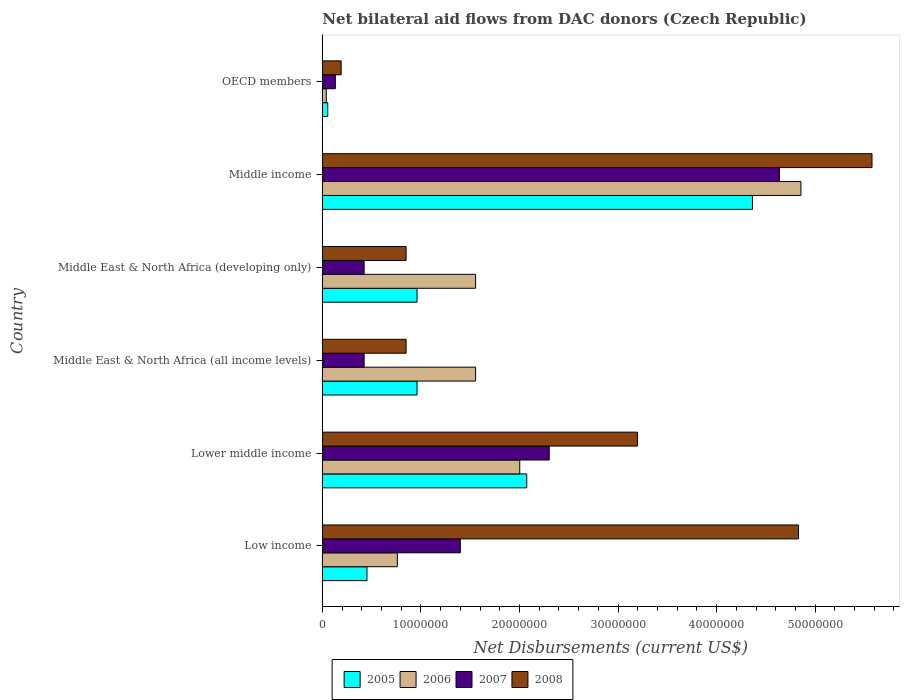How many different coloured bars are there?
Your answer should be compact. 4. Are the number of bars per tick equal to the number of legend labels?
Keep it short and to the point. Yes. How many bars are there on the 2nd tick from the top?
Offer a very short reply. 4. How many bars are there on the 6th tick from the bottom?
Your answer should be very brief. 4. In how many cases, is the number of bars for a given country not equal to the number of legend labels?
Provide a succinct answer. 0. What is the net bilateral aid flows in 2005 in Lower middle income?
Offer a terse response. 2.07e+07. Across all countries, what is the maximum net bilateral aid flows in 2008?
Keep it short and to the point. 5.58e+07. Across all countries, what is the minimum net bilateral aid flows in 2007?
Offer a very short reply. 1.32e+06. What is the total net bilateral aid flows in 2008 in the graph?
Your answer should be very brief. 1.55e+08. What is the difference between the net bilateral aid flows in 2008 in Middle East & North Africa (all income levels) and that in Middle income?
Offer a very short reply. -4.73e+07. What is the difference between the net bilateral aid flows in 2007 in Middle East & North Africa (all income levels) and the net bilateral aid flows in 2005 in Lower middle income?
Give a very brief answer. -1.65e+07. What is the average net bilateral aid flows in 2007 per country?
Your answer should be compact. 1.55e+07. What is the difference between the net bilateral aid flows in 2005 and net bilateral aid flows in 2006 in Middle East & North Africa (developing only)?
Your answer should be compact. -5.94e+06. What is the ratio of the net bilateral aid flows in 2008 in Low income to that in Middle East & North Africa (all income levels)?
Make the answer very short. 5.68. Is the difference between the net bilateral aid flows in 2005 in Lower middle income and Middle East & North Africa (developing only) greater than the difference between the net bilateral aid flows in 2006 in Lower middle income and Middle East & North Africa (developing only)?
Make the answer very short. Yes. What is the difference between the highest and the second highest net bilateral aid flows in 2005?
Offer a terse response. 2.29e+07. What is the difference between the highest and the lowest net bilateral aid flows in 2006?
Offer a terse response. 4.82e+07. What does the 2nd bar from the top in Middle East & North Africa (all income levels) represents?
Make the answer very short. 2007. Is it the case that in every country, the sum of the net bilateral aid flows in 2006 and net bilateral aid flows in 2005 is greater than the net bilateral aid flows in 2008?
Your answer should be very brief. No. Are all the bars in the graph horizontal?
Provide a succinct answer. Yes. How many countries are there in the graph?
Offer a very short reply. 6. What is the difference between two consecutive major ticks on the X-axis?
Your response must be concise. 1.00e+07. Are the values on the major ticks of X-axis written in scientific E-notation?
Keep it short and to the point. No. Does the graph contain any zero values?
Ensure brevity in your answer.  No. Does the graph contain grids?
Your answer should be compact. No. Where does the legend appear in the graph?
Keep it short and to the point. Bottom center. How are the legend labels stacked?
Ensure brevity in your answer.  Horizontal. What is the title of the graph?
Keep it short and to the point. Net bilateral aid flows from DAC donors (Czech Republic). What is the label or title of the X-axis?
Offer a terse response. Net Disbursements (current US$). What is the Net Disbursements (current US$) of 2005 in Low income?
Give a very brief answer. 4.53e+06. What is the Net Disbursements (current US$) in 2006 in Low income?
Keep it short and to the point. 7.61e+06. What is the Net Disbursements (current US$) in 2007 in Low income?
Your answer should be very brief. 1.40e+07. What is the Net Disbursements (current US$) in 2008 in Low income?
Keep it short and to the point. 4.83e+07. What is the Net Disbursements (current US$) in 2005 in Lower middle income?
Keep it short and to the point. 2.07e+07. What is the Net Disbursements (current US$) in 2006 in Lower middle income?
Make the answer very short. 2.00e+07. What is the Net Disbursements (current US$) in 2007 in Lower middle income?
Your response must be concise. 2.30e+07. What is the Net Disbursements (current US$) of 2008 in Lower middle income?
Offer a very short reply. 3.20e+07. What is the Net Disbursements (current US$) in 2005 in Middle East & North Africa (all income levels)?
Offer a very short reply. 9.61e+06. What is the Net Disbursements (current US$) of 2006 in Middle East & North Africa (all income levels)?
Make the answer very short. 1.56e+07. What is the Net Disbursements (current US$) in 2007 in Middle East & North Africa (all income levels)?
Give a very brief answer. 4.24e+06. What is the Net Disbursements (current US$) of 2008 in Middle East & North Africa (all income levels)?
Offer a terse response. 8.50e+06. What is the Net Disbursements (current US$) in 2005 in Middle East & North Africa (developing only)?
Offer a very short reply. 9.61e+06. What is the Net Disbursements (current US$) in 2006 in Middle East & North Africa (developing only)?
Offer a very short reply. 1.56e+07. What is the Net Disbursements (current US$) of 2007 in Middle East & North Africa (developing only)?
Provide a short and direct response. 4.24e+06. What is the Net Disbursements (current US$) of 2008 in Middle East & North Africa (developing only)?
Offer a terse response. 8.50e+06. What is the Net Disbursements (current US$) in 2005 in Middle income?
Your answer should be very brief. 4.36e+07. What is the Net Disbursements (current US$) of 2006 in Middle income?
Make the answer very short. 4.86e+07. What is the Net Disbursements (current US$) of 2007 in Middle income?
Provide a succinct answer. 4.64e+07. What is the Net Disbursements (current US$) in 2008 in Middle income?
Your response must be concise. 5.58e+07. What is the Net Disbursements (current US$) in 2006 in OECD members?
Keep it short and to the point. 4.00e+05. What is the Net Disbursements (current US$) of 2007 in OECD members?
Make the answer very short. 1.32e+06. What is the Net Disbursements (current US$) in 2008 in OECD members?
Offer a very short reply. 1.91e+06. Across all countries, what is the maximum Net Disbursements (current US$) in 2005?
Offer a very short reply. 4.36e+07. Across all countries, what is the maximum Net Disbursements (current US$) in 2006?
Offer a terse response. 4.86e+07. Across all countries, what is the maximum Net Disbursements (current US$) in 2007?
Offer a terse response. 4.64e+07. Across all countries, what is the maximum Net Disbursements (current US$) in 2008?
Your answer should be compact. 5.58e+07. Across all countries, what is the minimum Net Disbursements (current US$) of 2005?
Your response must be concise. 5.50e+05. Across all countries, what is the minimum Net Disbursements (current US$) of 2006?
Provide a succinct answer. 4.00e+05. Across all countries, what is the minimum Net Disbursements (current US$) in 2007?
Offer a very short reply. 1.32e+06. Across all countries, what is the minimum Net Disbursements (current US$) in 2008?
Offer a very short reply. 1.91e+06. What is the total Net Disbursements (current US$) of 2005 in the graph?
Offer a very short reply. 8.87e+07. What is the total Net Disbursements (current US$) of 2006 in the graph?
Offer a terse response. 1.08e+08. What is the total Net Disbursements (current US$) in 2007 in the graph?
Make the answer very short. 9.32e+07. What is the total Net Disbursements (current US$) of 2008 in the graph?
Provide a succinct answer. 1.55e+08. What is the difference between the Net Disbursements (current US$) of 2005 in Low income and that in Lower middle income?
Your answer should be compact. -1.62e+07. What is the difference between the Net Disbursements (current US$) of 2006 in Low income and that in Lower middle income?
Your answer should be very brief. -1.24e+07. What is the difference between the Net Disbursements (current US$) in 2007 in Low income and that in Lower middle income?
Provide a succinct answer. -9.02e+06. What is the difference between the Net Disbursements (current US$) in 2008 in Low income and that in Lower middle income?
Provide a short and direct response. 1.63e+07. What is the difference between the Net Disbursements (current US$) in 2005 in Low income and that in Middle East & North Africa (all income levels)?
Provide a succinct answer. -5.08e+06. What is the difference between the Net Disbursements (current US$) of 2006 in Low income and that in Middle East & North Africa (all income levels)?
Make the answer very short. -7.94e+06. What is the difference between the Net Disbursements (current US$) of 2007 in Low income and that in Middle East & North Africa (all income levels)?
Provide a succinct answer. 9.76e+06. What is the difference between the Net Disbursements (current US$) of 2008 in Low income and that in Middle East & North Africa (all income levels)?
Your response must be concise. 3.98e+07. What is the difference between the Net Disbursements (current US$) of 2005 in Low income and that in Middle East & North Africa (developing only)?
Your answer should be compact. -5.08e+06. What is the difference between the Net Disbursements (current US$) in 2006 in Low income and that in Middle East & North Africa (developing only)?
Make the answer very short. -7.94e+06. What is the difference between the Net Disbursements (current US$) of 2007 in Low income and that in Middle East & North Africa (developing only)?
Offer a terse response. 9.76e+06. What is the difference between the Net Disbursements (current US$) of 2008 in Low income and that in Middle East & North Africa (developing only)?
Offer a very short reply. 3.98e+07. What is the difference between the Net Disbursements (current US$) of 2005 in Low income and that in Middle income?
Provide a succinct answer. -3.91e+07. What is the difference between the Net Disbursements (current US$) in 2006 in Low income and that in Middle income?
Offer a terse response. -4.10e+07. What is the difference between the Net Disbursements (current US$) in 2007 in Low income and that in Middle income?
Keep it short and to the point. -3.24e+07. What is the difference between the Net Disbursements (current US$) in 2008 in Low income and that in Middle income?
Give a very brief answer. -7.46e+06. What is the difference between the Net Disbursements (current US$) in 2005 in Low income and that in OECD members?
Ensure brevity in your answer.  3.98e+06. What is the difference between the Net Disbursements (current US$) of 2006 in Low income and that in OECD members?
Ensure brevity in your answer.  7.21e+06. What is the difference between the Net Disbursements (current US$) in 2007 in Low income and that in OECD members?
Your answer should be compact. 1.27e+07. What is the difference between the Net Disbursements (current US$) in 2008 in Low income and that in OECD members?
Provide a succinct answer. 4.64e+07. What is the difference between the Net Disbursements (current US$) of 2005 in Lower middle income and that in Middle East & North Africa (all income levels)?
Your answer should be compact. 1.11e+07. What is the difference between the Net Disbursements (current US$) of 2006 in Lower middle income and that in Middle East & North Africa (all income levels)?
Your response must be concise. 4.48e+06. What is the difference between the Net Disbursements (current US$) in 2007 in Lower middle income and that in Middle East & North Africa (all income levels)?
Give a very brief answer. 1.88e+07. What is the difference between the Net Disbursements (current US$) in 2008 in Lower middle income and that in Middle East & North Africa (all income levels)?
Ensure brevity in your answer.  2.35e+07. What is the difference between the Net Disbursements (current US$) in 2005 in Lower middle income and that in Middle East & North Africa (developing only)?
Offer a terse response. 1.11e+07. What is the difference between the Net Disbursements (current US$) of 2006 in Lower middle income and that in Middle East & North Africa (developing only)?
Your response must be concise. 4.48e+06. What is the difference between the Net Disbursements (current US$) of 2007 in Lower middle income and that in Middle East & North Africa (developing only)?
Ensure brevity in your answer.  1.88e+07. What is the difference between the Net Disbursements (current US$) of 2008 in Lower middle income and that in Middle East & North Africa (developing only)?
Provide a succinct answer. 2.35e+07. What is the difference between the Net Disbursements (current US$) of 2005 in Lower middle income and that in Middle income?
Provide a succinct answer. -2.29e+07. What is the difference between the Net Disbursements (current US$) of 2006 in Lower middle income and that in Middle income?
Offer a terse response. -2.85e+07. What is the difference between the Net Disbursements (current US$) in 2007 in Lower middle income and that in Middle income?
Your answer should be very brief. -2.34e+07. What is the difference between the Net Disbursements (current US$) in 2008 in Lower middle income and that in Middle income?
Your answer should be compact. -2.38e+07. What is the difference between the Net Disbursements (current US$) in 2005 in Lower middle income and that in OECD members?
Make the answer very short. 2.02e+07. What is the difference between the Net Disbursements (current US$) of 2006 in Lower middle income and that in OECD members?
Provide a succinct answer. 1.96e+07. What is the difference between the Net Disbursements (current US$) of 2007 in Lower middle income and that in OECD members?
Provide a succinct answer. 2.17e+07. What is the difference between the Net Disbursements (current US$) of 2008 in Lower middle income and that in OECD members?
Give a very brief answer. 3.01e+07. What is the difference between the Net Disbursements (current US$) of 2007 in Middle East & North Africa (all income levels) and that in Middle East & North Africa (developing only)?
Offer a very short reply. 0. What is the difference between the Net Disbursements (current US$) of 2005 in Middle East & North Africa (all income levels) and that in Middle income?
Your answer should be compact. -3.40e+07. What is the difference between the Net Disbursements (current US$) in 2006 in Middle East & North Africa (all income levels) and that in Middle income?
Keep it short and to the point. -3.30e+07. What is the difference between the Net Disbursements (current US$) of 2007 in Middle East & North Africa (all income levels) and that in Middle income?
Your response must be concise. -4.21e+07. What is the difference between the Net Disbursements (current US$) in 2008 in Middle East & North Africa (all income levels) and that in Middle income?
Provide a succinct answer. -4.73e+07. What is the difference between the Net Disbursements (current US$) of 2005 in Middle East & North Africa (all income levels) and that in OECD members?
Your response must be concise. 9.06e+06. What is the difference between the Net Disbursements (current US$) of 2006 in Middle East & North Africa (all income levels) and that in OECD members?
Provide a succinct answer. 1.52e+07. What is the difference between the Net Disbursements (current US$) in 2007 in Middle East & North Africa (all income levels) and that in OECD members?
Ensure brevity in your answer.  2.92e+06. What is the difference between the Net Disbursements (current US$) of 2008 in Middle East & North Africa (all income levels) and that in OECD members?
Ensure brevity in your answer.  6.59e+06. What is the difference between the Net Disbursements (current US$) in 2005 in Middle East & North Africa (developing only) and that in Middle income?
Keep it short and to the point. -3.40e+07. What is the difference between the Net Disbursements (current US$) in 2006 in Middle East & North Africa (developing only) and that in Middle income?
Give a very brief answer. -3.30e+07. What is the difference between the Net Disbursements (current US$) of 2007 in Middle East & North Africa (developing only) and that in Middle income?
Offer a very short reply. -4.21e+07. What is the difference between the Net Disbursements (current US$) of 2008 in Middle East & North Africa (developing only) and that in Middle income?
Your response must be concise. -4.73e+07. What is the difference between the Net Disbursements (current US$) of 2005 in Middle East & North Africa (developing only) and that in OECD members?
Provide a succinct answer. 9.06e+06. What is the difference between the Net Disbursements (current US$) of 2006 in Middle East & North Africa (developing only) and that in OECD members?
Offer a terse response. 1.52e+07. What is the difference between the Net Disbursements (current US$) in 2007 in Middle East & North Africa (developing only) and that in OECD members?
Your response must be concise. 2.92e+06. What is the difference between the Net Disbursements (current US$) of 2008 in Middle East & North Africa (developing only) and that in OECD members?
Your response must be concise. 6.59e+06. What is the difference between the Net Disbursements (current US$) of 2005 in Middle income and that in OECD members?
Ensure brevity in your answer.  4.31e+07. What is the difference between the Net Disbursements (current US$) in 2006 in Middle income and that in OECD members?
Keep it short and to the point. 4.82e+07. What is the difference between the Net Disbursements (current US$) of 2007 in Middle income and that in OECD members?
Your response must be concise. 4.51e+07. What is the difference between the Net Disbursements (current US$) of 2008 in Middle income and that in OECD members?
Offer a very short reply. 5.39e+07. What is the difference between the Net Disbursements (current US$) of 2005 in Low income and the Net Disbursements (current US$) of 2006 in Lower middle income?
Provide a short and direct response. -1.55e+07. What is the difference between the Net Disbursements (current US$) of 2005 in Low income and the Net Disbursements (current US$) of 2007 in Lower middle income?
Make the answer very short. -1.85e+07. What is the difference between the Net Disbursements (current US$) in 2005 in Low income and the Net Disbursements (current US$) in 2008 in Lower middle income?
Your answer should be very brief. -2.74e+07. What is the difference between the Net Disbursements (current US$) of 2006 in Low income and the Net Disbursements (current US$) of 2007 in Lower middle income?
Offer a very short reply. -1.54e+07. What is the difference between the Net Disbursements (current US$) in 2006 in Low income and the Net Disbursements (current US$) in 2008 in Lower middle income?
Provide a succinct answer. -2.44e+07. What is the difference between the Net Disbursements (current US$) in 2007 in Low income and the Net Disbursements (current US$) in 2008 in Lower middle income?
Your response must be concise. -1.80e+07. What is the difference between the Net Disbursements (current US$) of 2005 in Low income and the Net Disbursements (current US$) of 2006 in Middle East & North Africa (all income levels)?
Give a very brief answer. -1.10e+07. What is the difference between the Net Disbursements (current US$) in 2005 in Low income and the Net Disbursements (current US$) in 2008 in Middle East & North Africa (all income levels)?
Your answer should be very brief. -3.97e+06. What is the difference between the Net Disbursements (current US$) of 2006 in Low income and the Net Disbursements (current US$) of 2007 in Middle East & North Africa (all income levels)?
Your answer should be very brief. 3.37e+06. What is the difference between the Net Disbursements (current US$) of 2006 in Low income and the Net Disbursements (current US$) of 2008 in Middle East & North Africa (all income levels)?
Ensure brevity in your answer.  -8.90e+05. What is the difference between the Net Disbursements (current US$) of 2007 in Low income and the Net Disbursements (current US$) of 2008 in Middle East & North Africa (all income levels)?
Give a very brief answer. 5.50e+06. What is the difference between the Net Disbursements (current US$) in 2005 in Low income and the Net Disbursements (current US$) in 2006 in Middle East & North Africa (developing only)?
Keep it short and to the point. -1.10e+07. What is the difference between the Net Disbursements (current US$) of 2005 in Low income and the Net Disbursements (current US$) of 2007 in Middle East & North Africa (developing only)?
Ensure brevity in your answer.  2.90e+05. What is the difference between the Net Disbursements (current US$) in 2005 in Low income and the Net Disbursements (current US$) in 2008 in Middle East & North Africa (developing only)?
Provide a succinct answer. -3.97e+06. What is the difference between the Net Disbursements (current US$) in 2006 in Low income and the Net Disbursements (current US$) in 2007 in Middle East & North Africa (developing only)?
Your response must be concise. 3.37e+06. What is the difference between the Net Disbursements (current US$) in 2006 in Low income and the Net Disbursements (current US$) in 2008 in Middle East & North Africa (developing only)?
Offer a terse response. -8.90e+05. What is the difference between the Net Disbursements (current US$) in 2007 in Low income and the Net Disbursements (current US$) in 2008 in Middle East & North Africa (developing only)?
Offer a very short reply. 5.50e+06. What is the difference between the Net Disbursements (current US$) in 2005 in Low income and the Net Disbursements (current US$) in 2006 in Middle income?
Ensure brevity in your answer.  -4.40e+07. What is the difference between the Net Disbursements (current US$) of 2005 in Low income and the Net Disbursements (current US$) of 2007 in Middle income?
Ensure brevity in your answer.  -4.18e+07. What is the difference between the Net Disbursements (current US$) of 2005 in Low income and the Net Disbursements (current US$) of 2008 in Middle income?
Provide a succinct answer. -5.12e+07. What is the difference between the Net Disbursements (current US$) of 2006 in Low income and the Net Disbursements (current US$) of 2007 in Middle income?
Provide a succinct answer. -3.88e+07. What is the difference between the Net Disbursements (current US$) in 2006 in Low income and the Net Disbursements (current US$) in 2008 in Middle income?
Your response must be concise. -4.82e+07. What is the difference between the Net Disbursements (current US$) in 2007 in Low income and the Net Disbursements (current US$) in 2008 in Middle income?
Provide a short and direct response. -4.18e+07. What is the difference between the Net Disbursements (current US$) of 2005 in Low income and the Net Disbursements (current US$) of 2006 in OECD members?
Provide a succinct answer. 4.13e+06. What is the difference between the Net Disbursements (current US$) of 2005 in Low income and the Net Disbursements (current US$) of 2007 in OECD members?
Ensure brevity in your answer.  3.21e+06. What is the difference between the Net Disbursements (current US$) of 2005 in Low income and the Net Disbursements (current US$) of 2008 in OECD members?
Keep it short and to the point. 2.62e+06. What is the difference between the Net Disbursements (current US$) of 2006 in Low income and the Net Disbursements (current US$) of 2007 in OECD members?
Your answer should be very brief. 6.29e+06. What is the difference between the Net Disbursements (current US$) of 2006 in Low income and the Net Disbursements (current US$) of 2008 in OECD members?
Your response must be concise. 5.70e+06. What is the difference between the Net Disbursements (current US$) of 2007 in Low income and the Net Disbursements (current US$) of 2008 in OECD members?
Ensure brevity in your answer.  1.21e+07. What is the difference between the Net Disbursements (current US$) in 2005 in Lower middle income and the Net Disbursements (current US$) in 2006 in Middle East & North Africa (all income levels)?
Your answer should be very brief. 5.19e+06. What is the difference between the Net Disbursements (current US$) of 2005 in Lower middle income and the Net Disbursements (current US$) of 2007 in Middle East & North Africa (all income levels)?
Your answer should be compact. 1.65e+07. What is the difference between the Net Disbursements (current US$) of 2005 in Lower middle income and the Net Disbursements (current US$) of 2008 in Middle East & North Africa (all income levels)?
Provide a succinct answer. 1.22e+07. What is the difference between the Net Disbursements (current US$) of 2006 in Lower middle income and the Net Disbursements (current US$) of 2007 in Middle East & North Africa (all income levels)?
Your response must be concise. 1.58e+07. What is the difference between the Net Disbursements (current US$) of 2006 in Lower middle income and the Net Disbursements (current US$) of 2008 in Middle East & North Africa (all income levels)?
Provide a succinct answer. 1.15e+07. What is the difference between the Net Disbursements (current US$) of 2007 in Lower middle income and the Net Disbursements (current US$) of 2008 in Middle East & North Africa (all income levels)?
Your answer should be compact. 1.45e+07. What is the difference between the Net Disbursements (current US$) in 2005 in Lower middle income and the Net Disbursements (current US$) in 2006 in Middle East & North Africa (developing only)?
Provide a short and direct response. 5.19e+06. What is the difference between the Net Disbursements (current US$) of 2005 in Lower middle income and the Net Disbursements (current US$) of 2007 in Middle East & North Africa (developing only)?
Your answer should be very brief. 1.65e+07. What is the difference between the Net Disbursements (current US$) in 2005 in Lower middle income and the Net Disbursements (current US$) in 2008 in Middle East & North Africa (developing only)?
Your answer should be compact. 1.22e+07. What is the difference between the Net Disbursements (current US$) in 2006 in Lower middle income and the Net Disbursements (current US$) in 2007 in Middle East & North Africa (developing only)?
Your answer should be compact. 1.58e+07. What is the difference between the Net Disbursements (current US$) of 2006 in Lower middle income and the Net Disbursements (current US$) of 2008 in Middle East & North Africa (developing only)?
Offer a terse response. 1.15e+07. What is the difference between the Net Disbursements (current US$) in 2007 in Lower middle income and the Net Disbursements (current US$) in 2008 in Middle East & North Africa (developing only)?
Provide a short and direct response. 1.45e+07. What is the difference between the Net Disbursements (current US$) of 2005 in Lower middle income and the Net Disbursements (current US$) of 2006 in Middle income?
Offer a terse response. -2.78e+07. What is the difference between the Net Disbursements (current US$) in 2005 in Lower middle income and the Net Disbursements (current US$) in 2007 in Middle income?
Your answer should be very brief. -2.56e+07. What is the difference between the Net Disbursements (current US$) in 2005 in Lower middle income and the Net Disbursements (current US$) in 2008 in Middle income?
Make the answer very short. -3.50e+07. What is the difference between the Net Disbursements (current US$) of 2006 in Lower middle income and the Net Disbursements (current US$) of 2007 in Middle income?
Offer a terse response. -2.64e+07. What is the difference between the Net Disbursements (current US$) in 2006 in Lower middle income and the Net Disbursements (current US$) in 2008 in Middle income?
Your answer should be compact. -3.57e+07. What is the difference between the Net Disbursements (current US$) of 2007 in Lower middle income and the Net Disbursements (current US$) of 2008 in Middle income?
Offer a very short reply. -3.28e+07. What is the difference between the Net Disbursements (current US$) of 2005 in Lower middle income and the Net Disbursements (current US$) of 2006 in OECD members?
Ensure brevity in your answer.  2.03e+07. What is the difference between the Net Disbursements (current US$) of 2005 in Lower middle income and the Net Disbursements (current US$) of 2007 in OECD members?
Give a very brief answer. 1.94e+07. What is the difference between the Net Disbursements (current US$) in 2005 in Lower middle income and the Net Disbursements (current US$) in 2008 in OECD members?
Provide a succinct answer. 1.88e+07. What is the difference between the Net Disbursements (current US$) of 2006 in Lower middle income and the Net Disbursements (current US$) of 2007 in OECD members?
Give a very brief answer. 1.87e+07. What is the difference between the Net Disbursements (current US$) in 2006 in Lower middle income and the Net Disbursements (current US$) in 2008 in OECD members?
Ensure brevity in your answer.  1.81e+07. What is the difference between the Net Disbursements (current US$) in 2007 in Lower middle income and the Net Disbursements (current US$) in 2008 in OECD members?
Offer a very short reply. 2.11e+07. What is the difference between the Net Disbursements (current US$) of 2005 in Middle East & North Africa (all income levels) and the Net Disbursements (current US$) of 2006 in Middle East & North Africa (developing only)?
Provide a short and direct response. -5.94e+06. What is the difference between the Net Disbursements (current US$) of 2005 in Middle East & North Africa (all income levels) and the Net Disbursements (current US$) of 2007 in Middle East & North Africa (developing only)?
Give a very brief answer. 5.37e+06. What is the difference between the Net Disbursements (current US$) of 2005 in Middle East & North Africa (all income levels) and the Net Disbursements (current US$) of 2008 in Middle East & North Africa (developing only)?
Provide a short and direct response. 1.11e+06. What is the difference between the Net Disbursements (current US$) in 2006 in Middle East & North Africa (all income levels) and the Net Disbursements (current US$) in 2007 in Middle East & North Africa (developing only)?
Offer a very short reply. 1.13e+07. What is the difference between the Net Disbursements (current US$) in 2006 in Middle East & North Africa (all income levels) and the Net Disbursements (current US$) in 2008 in Middle East & North Africa (developing only)?
Provide a succinct answer. 7.05e+06. What is the difference between the Net Disbursements (current US$) in 2007 in Middle East & North Africa (all income levels) and the Net Disbursements (current US$) in 2008 in Middle East & North Africa (developing only)?
Offer a terse response. -4.26e+06. What is the difference between the Net Disbursements (current US$) of 2005 in Middle East & North Africa (all income levels) and the Net Disbursements (current US$) of 2006 in Middle income?
Your answer should be very brief. -3.90e+07. What is the difference between the Net Disbursements (current US$) of 2005 in Middle East & North Africa (all income levels) and the Net Disbursements (current US$) of 2007 in Middle income?
Your response must be concise. -3.68e+07. What is the difference between the Net Disbursements (current US$) of 2005 in Middle East & North Africa (all income levels) and the Net Disbursements (current US$) of 2008 in Middle income?
Offer a very short reply. -4.62e+07. What is the difference between the Net Disbursements (current US$) in 2006 in Middle East & North Africa (all income levels) and the Net Disbursements (current US$) in 2007 in Middle income?
Your response must be concise. -3.08e+07. What is the difference between the Net Disbursements (current US$) in 2006 in Middle East & North Africa (all income levels) and the Net Disbursements (current US$) in 2008 in Middle income?
Make the answer very short. -4.02e+07. What is the difference between the Net Disbursements (current US$) in 2007 in Middle East & North Africa (all income levels) and the Net Disbursements (current US$) in 2008 in Middle income?
Provide a short and direct response. -5.15e+07. What is the difference between the Net Disbursements (current US$) of 2005 in Middle East & North Africa (all income levels) and the Net Disbursements (current US$) of 2006 in OECD members?
Your response must be concise. 9.21e+06. What is the difference between the Net Disbursements (current US$) of 2005 in Middle East & North Africa (all income levels) and the Net Disbursements (current US$) of 2007 in OECD members?
Provide a succinct answer. 8.29e+06. What is the difference between the Net Disbursements (current US$) of 2005 in Middle East & North Africa (all income levels) and the Net Disbursements (current US$) of 2008 in OECD members?
Give a very brief answer. 7.70e+06. What is the difference between the Net Disbursements (current US$) of 2006 in Middle East & North Africa (all income levels) and the Net Disbursements (current US$) of 2007 in OECD members?
Make the answer very short. 1.42e+07. What is the difference between the Net Disbursements (current US$) in 2006 in Middle East & North Africa (all income levels) and the Net Disbursements (current US$) in 2008 in OECD members?
Your answer should be very brief. 1.36e+07. What is the difference between the Net Disbursements (current US$) in 2007 in Middle East & North Africa (all income levels) and the Net Disbursements (current US$) in 2008 in OECD members?
Give a very brief answer. 2.33e+06. What is the difference between the Net Disbursements (current US$) in 2005 in Middle East & North Africa (developing only) and the Net Disbursements (current US$) in 2006 in Middle income?
Provide a short and direct response. -3.90e+07. What is the difference between the Net Disbursements (current US$) of 2005 in Middle East & North Africa (developing only) and the Net Disbursements (current US$) of 2007 in Middle income?
Your response must be concise. -3.68e+07. What is the difference between the Net Disbursements (current US$) in 2005 in Middle East & North Africa (developing only) and the Net Disbursements (current US$) in 2008 in Middle income?
Your response must be concise. -4.62e+07. What is the difference between the Net Disbursements (current US$) of 2006 in Middle East & North Africa (developing only) and the Net Disbursements (current US$) of 2007 in Middle income?
Your answer should be compact. -3.08e+07. What is the difference between the Net Disbursements (current US$) of 2006 in Middle East & North Africa (developing only) and the Net Disbursements (current US$) of 2008 in Middle income?
Offer a terse response. -4.02e+07. What is the difference between the Net Disbursements (current US$) in 2007 in Middle East & North Africa (developing only) and the Net Disbursements (current US$) in 2008 in Middle income?
Ensure brevity in your answer.  -5.15e+07. What is the difference between the Net Disbursements (current US$) in 2005 in Middle East & North Africa (developing only) and the Net Disbursements (current US$) in 2006 in OECD members?
Provide a succinct answer. 9.21e+06. What is the difference between the Net Disbursements (current US$) of 2005 in Middle East & North Africa (developing only) and the Net Disbursements (current US$) of 2007 in OECD members?
Your answer should be very brief. 8.29e+06. What is the difference between the Net Disbursements (current US$) in 2005 in Middle East & North Africa (developing only) and the Net Disbursements (current US$) in 2008 in OECD members?
Offer a very short reply. 7.70e+06. What is the difference between the Net Disbursements (current US$) of 2006 in Middle East & North Africa (developing only) and the Net Disbursements (current US$) of 2007 in OECD members?
Make the answer very short. 1.42e+07. What is the difference between the Net Disbursements (current US$) in 2006 in Middle East & North Africa (developing only) and the Net Disbursements (current US$) in 2008 in OECD members?
Your response must be concise. 1.36e+07. What is the difference between the Net Disbursements (current US$) in 2007 in Middle East & North Africa (developing only) and the Net Disbursements (current US$) in 2008 in OECD members?
Your answer should be very brief. 2.33e+06. What is the difference between the Net Disbursements (current US$) in 2005 in Middle income and the Net Disbursements (current US$) in 2006 in OECD members?
Your response must be concise. 4.32e+07. What is the difference between the Net Disbursements (current US$) of 2005 in Middle income and the Net Disbursements (current US$) of 2007 in OECD members?
Provide a short and direct response. 4.23e+07. What is the difference between the Net Disbursements (current US$) of 2005 in Middle income and the Net Disbursements (current US$) of 2008 in OECD members?
Offer a terse response. 4.17e+07. What is the difference between the Net Disbursements (current US$) in 2006 in Middle income and the Net Disbursements (current US$) in 2007 in OECD members?
Give a very brief answer. 4.72e+07. What is the difference between the Net Disbursements (current US$) in 2006 in Middle income and the Net Disbursements (current US$) in 2008 in OECD members?
Offer a terse response. 4.66e+07. What is the difference between the Net Disbursements (current US$) in 2007 in Middle income and the Net Disbursements (current US$) in 2008 in OECD members?
Your answer should be very brief. 4.45e+07. What is the average Net Disbursements (current US$) of 2005 per country?
Provide a short and direct response. 1.48e+07. What is the average Net Disbursements (current US$) in 2006 per country?
Provide a succinct answer. 1.80e+07. What is the average Net Disbursements (current US$) in 2007 per country?
Your answer should be very brief. 1.55e+07. What is the average Net Disbursements (current US$) in 2008 per country?
Provide a succinct answer. 2.58e+07. What is the difference between the Net Disbursements (current US$) of 2005 and Net Disbursements (current US$) of 2006 in Low income?
Your answer should be compact. -3.08e+06. What is the difference between the Net Disbursements (current US$) in 2005 and Net Disbursements (current US$) in 2007 in Low income?
Make the answer very short. -9.47e+06. What is the difference between the Net Disbursements (current US$) of 2005 and Net Disbursements (current US$) of 2008 in Low income?
Give a very brief answer. -4.38e+07. What is the difference between the Net Disbursements (current US$) of 2006 and Net Disbursements (current US$) of 2007 in Low income?
Give a very brief answer. -6.39e+06. What is the difference between the Net Disbursements (current US$) in 2006 and Net Disbursements (current US$) in 2008 in Low income?
Provide a short and direct response. -4.07e+07. What is the difference between the Net Disbursements (current US$) in 2007 and Net Disbursements (current US$) in 2008 in Low income?
Provide a succinct answer. -3.43e+07. What is the difference between the Net Disbursements (current US$) in 2005 and Net Disbursements (current US$) in 2006 in Lower middle income?
Provide a short and direct response. 7.10e+05. What is the difference between the Net Disbursements (current US$) in 2005 and Net Disbursements (current US$) in 2007 in Lower middle income?
Offer a terse response. -2.28e+06. What is the difference between the Net Disbursements (current US$) in 2005 and Net Disbursements (current US$) in 2008 in Lower middle income?
Ensure brevity in your answer.  -1.12e+07. What is the difference between the Net Disbursements (current US$) in 2006 and Net Disbursements (current US$) in 2007 in Lower middle income?
Provide a short and direct response. -2.99e+06. What is the difference between the Net Disbursements (current US$) of 2006 and Net Disbursements (current US$) of 2008 in Lower middle income?
Your answer should be very brief. -1.19e+07. What is the difference between the Net Disbursements (current US$) of 2007 and Net Disbursements (current US$) of 2008 in Lower middle income?
Offer a very short reply. -8.95e+06. What is the difference between the Net Disbursements (current US$) in 2005 and Net Disbursements (current US$) in 2006 in Middle East & North Africa (all income levels)?
Offer a terse response. -5.94e+06. What is the difference between the Net Disbursements (current US$) in 2005 and Net Disbursements (current US$) in 2007 in Middle East & North Africa (all income levels)?
Offer a terse response. 5.37e+06. What is the difference between the Net Disbursements (current US$) in 2005 and Net Disbursements (current US$) in 2008 in Middle East & North Africa (all income levels)?
Your response must be concise. 1.11e+06. What is the difference between the Net Disbursements (current US$) of 2006 and Net Disbursements (current US$) of 2007 in Middle East & North Africa (all income levels)?
Ensure brevity in your answer.  1.13e+07. What is the difference between the Net Disbursements (current US$) of 2006 and Net Disbursements (current US$) of 2008 in Middle East & North Africa (all income levels)?
Offer a very short reply. 7.05e+06. What is the difference between the Net Disbursements (current US$) in 2007 and Net Disbursements (current US$) in 2008 in Middle East & North Africa (all income levels)?
Offer a very short reply. -4.26e+06. What is the difference between the Net Disbursements (current US$) of 2005 and Net Disbursements (current US$) of 2006 in Middle East & North Africa (developing only)?
Offer a terse response. -5.94e+06. What is the difference between the Net Disbursements (current US$) in 2005 and Net Disbursements (current US$) in 2007 in Middle East & North Africa (developing only)?
Make the answer very short. 5.37e+06. What is the difference between the Net Disbursements (current US$) in 2005 and Net Disbursements (current US$) in 2008 in Middle East & North Africa (developing only)?
Give a very brief answer. 1.11e+06. What is the difference between the Net Disbursements (current US$) in 2006 and Net Disbursements (current US$) in 2007 in Middle East & North Africa (developing only)?
Provide a short and direct response. 1.13e+07. What is the difference between the Net Disbursements (current US$) in 2006 and Net Disbursements (current US$) in 2008 in Middle East & North Africa (developing only)?
Offer a very short reply. 7.05e+06. What is the difference between the Net Disbursements (current US$) of 2007 and Net Disbursements (current US$) of 2008 in Middle East & North Africa (developing only)?
Your answer should be compact. -4.26e+06. What is the difference between the Net Disbursements (current US$) in 2005 and Net Disbursements (current US$) in 2006 in Middle income?
Your answer should be very brief. -4.92e+06. What is the difference between the Net Disbursements (current US$) of 2005 and Net Disbursements (current US$) of 2007 in Middle income?
Provide a succinct answer. -2.74e+06. What is the difference between the Net Disbursements (current US$) in 2005 and Net Disbursements (current US$) in 2008 in Middle income?
Ensure brevity in your answer.  -1.21e+07. What is the difference between the Net Disbursements (current US$) of 2006 and Net Disbursements (current US$) of 2007 in Middle income?
Provide a succinct answer. 2.18e+06. What is the difference between the Net Disbursements (current US$) of 2006 and Net Disbursements (current US$) of 2008 in Middle income?
Your answer should be compact. -7.21e+06. What is the difference between the Net Disbursements (current US$) of 2007 and Net Disbursements (current US$) of 2008 in Middle income?
Your answer should be very brief. -9.39e+06. What is the difference between the Net Disbursements (current US$) in 2005 and Net Disbursements (current US$) in 2007 in OECD members?
Ensure brevity in your answer.  -7.70e+05. What is the difference between the Net Disbursements (current US$) of 2005 and Net Disbursements (current US$) of 2008 in OECD members?
Offer a terse response. -1.36e+06. What is the difference between the Net Disbursements (current US$) in 2006 and Net Disbursements (current US$) in 2007 in OECD members?
Provide a short and direct response. -9.20e+05. What is the difference between the Net Disbursements (current US$) in 2006 and Net Disbursements (current US$) in 2008 in OECD members?
Offer a very short reply. -1.51e+06. What is the difference between the Net Disbursements (current US$) of 2007 and Net Disbursements (current US$) of 2008 in OECD members?
Your response must be concise. -5.90e+05. What is the ratio of the Net Disbursements (current US$) of 2005 in Low income to that in Lower middle income?
Your answer should be compact. 0.22. What is the ratio of the Net Disbursements (current US$) of 2006 in Low income to that in Lower middle income?
Your answer should be compact. 0.38. What is the ratio of the Net Disbursements (current US$) in 2007 in Low income to that in Lower middle income?
Make the answer very short. 0.61. What is the ratio of the Net Disbursements (current US$) of 2008 in Low income to that in Lower middle income?
Provide a short and direct response. 1.51. What is the ratio of the Net Disbursements (current US$) in 2005 in Low income to that in Middle East & North Africa (all income levels)?
Offer a very short reply. 0.47. What is the ratio of the Net Disbursements (current US$) of 2006 in Low income to that in Middle East & North Africa (all income levels)?
Give a very brief answer. 0.49. What is the ratio of the Net Disbursements (current US$) in 2007 in Low income to that in Middle East & North Africa (all income levels)?
Give a very brief answer. 3.3. What is the ratio of the Net Disbursements (current US$) in 2008 in Low income to that in Middle East & North Africa (all income levels)?
Your answer should be very brief. 5.68. What is the ratio of the Net Disbursements (current US$) in 2005 in Low income to that in Middle East & North Africa (developing only)?
Your answer should be compact. 0.47. What is the ratio of the Net Disbursements (current US$) in 2006 in Low income to that in Middle East & North Africa (developing only)?
Offer a very short reply. 0.49. What is the ratio of the Net Disbursements (current US$) of 2007 in Low income to that in Middle East & North Africa (developing only)?
Offer a very short reply. 3.3. What is the ratio of the Net Disbursements (current US$) in 2008 in Low income to that in Middle East & North Africa (developing only)?
Your answer should be compact. 5.68. What is the ratio of the Net Disbursements (current US$) of 2005 in Low income to that in Middle income?
Your response must be concise. 0.1. What is the ratio of the Net Disbursements (current US$) in 2006 in Low income to that in Middle income?
Your answer should be very brief. 0.16. What is the ratio of the Net Disbursements (current US$) in 2007 in Low income to that in Middle income?
Make the answer very short. 0.3. What is the ratio of the Net Disbursements (current US$) in 2008 in Low income to that in Middle income?
Your answer should be compact. 0.87. What is the ratio of the Net Disbursements (current US$) of 2005 in Low income to that in OECD members?
Your answer should be very brief. 8.24. What is the ratio of the Net Disbursements (current US$) of 2006 in Low income to that in OECD members?
Provide a succinct answer. 19.02. What is the ratio of the Net Disbursements (current US$) of 2007 in Low income to that in OECD members?
Your response must be concise. 10.61. What is the ratio of the Net Disbursements (current US$) of 2008 in Low income to that in OECD members?
Your response must be concise. 25.29. What is the ratio of the Net Disbursements (current US$) of 2005 in Lower middle income to that in Middle East & North Africa (all income levels)?
Make the answer very short. 2.16. What is the ratio of the Net Disbursements (current US$) in 2006 in Lower middle income to that in Middle East & North Africa (all income levels)?
Keep it short and to the point. 1.29. What is the ratio of the Net Disbursements (current US$) in 2007 in Lower middle income to that in Middle East & North Africa (all income levels)?
Ensure brevity in your answer.  5.43. What is the ratio of the Net Disbursements (current US$) in 2008 in Lower middle income to that in Middle East & North Africa (all income levels)?
Provide a short and direct response. 3.76. What is the ratio of the Net Disbursements (current US$) in 2005 in Lower middle income to that in Middle East & North Africa (developing only)?
Provide a short and direct response. 2.16. What is the ratio of the Net Disbursements (current US$) in 2006 in Lower middle income to that in Middle East & North Africa (developing only)?
Make the answer very short. 1.29. What is the ratio of the Net Disbursements (current US$) of 2007 in Lower middle income to that in Middle East & North Africa (developing only)?
Ensure brevity in your answer.  5.43. What is the ratio of the Net Disbursements (current US$) in 2008 in Lower middle income to that in Middle East & North Africa (developing only)?
Provide a short and direct response. 3.76. What is the ratio of the Net Disbursements (current US$) of 2005 in Lower middle income to that in Middle income?
Give a very brief answer. 0.48. What is the ratio of the Net Disbursements (current US$) in 2006 in Lower middle income to that in Middle income?
Your response must be concise. 0.41. What is the ratio of the Net Disbursements (current US$) in 2007 in Lower middle income to that in Middle income?
Offer a terse response. 0.5. What is the ratio of the Net Disbursements (current US$) of 2008 in Lower middle income to that in Middle income?
Ensure brevity in your answer.  0.57. What is the ratio of the Net Disbursements (current US$) in 2005 in Lower middle income to that in OECD members?
Offer a very short reply. 37.71. What is the ratio of the Net Disbursements (current US$) in 2006 in Lower middle income to that in OECD members?
Your response must be concise. 50.08. What is the ratio of the Net Disbursements (current US$) in 2007 in Lower middle income to that in OECD members?
Make the answer very short. 17.44. What is the ratio of the Net Disbursements (current US$) of 2008 in Lower middle income to that in OECD members?
Offer a very short reply. 16.74. What is the ratio of the Net Disbursements (current US$) of 2006 in Middle East & North Africa (all income levels) to that in Middle East & North Africa (developing only)?
Your response must be concise. 1. What is the ratio of the Net Disbursements (current US$) in 2005 in Middle East & North Africa (all income levels) to that in Middle income?
Your answer should be very brief. 0.22. What is the ratio of the Net Disbursements (current US$) of 2006 in Middle East & North Africa (all income levels) to that in Middle income?
Offer a very short reply. 0.32. What is the ratio of the Net Disbursements (current US$) of 2007 in Middle East & North Africa (all income levels) to that in Middle income?
Make the answer very short. 0.09. What is the ratio of the Net Disbursements (current US$) in 2008 in Middle East & North Africa (all income levels) to that in Middle income?
Your answer should be very brief. 0.15. What is the ratio of the Net Disbursements (current US$) in 2005 in Middle East & North Africa (all income levels) to that in OECD members?
Make the answer very short. 17.47. What is the ratio of the Net Disbursements (current US$) in 2006 in Middle East & North Africa (all income levels) to that in OECD members?
Your answer should be very brief. 38.88. What is the ratio of the Net Disbursements (current US$) in 2007 in Middle East & North Africa (all income levels) to that in OECD members?
Give a very brief answer. 3.21. What is the ratio of the Net Disbursements (current US$) in 2008 in Middle East & North Africa (all income levels) to that in OECD members?
Make the answer very short. 4.45. What is the ratio of the Net Disbursements (current US$) of 2005 in Middle East & North Africa (developing only) to that in Middle income?
Your answer should be compact. 0.22. What is the ratio of the Net Disbursements (current US$) of 2006 in Middle East & North Africa (developing only) to that in Middle income?
Your answer should be very brief. 0.32. What is the ratio of the Net Disbursements (current US$) of 2007 in Middle East & North Africa (developing only) to that in Middle income?
Offer a terse response. 0.09. What is the ratio of the Net Disbursements (current US$) of 2008 in Middle East & North Africa (developing only) to that in Middle income?
Provide a short and direct response. 0.15. What is the ratio of the Net Disbursements (current US$) in 2005 in Middle East & North Africa (developing only) to that in OECD members?
Make the answer very short. 17.47. What is the ratio of the Net Disbursements (current US$) in 2006 in Middle East & North Africa (developing only) to that in OECD members?
Your answer should be very brief. 38.88. What is the ratio of the Net Disbursements (current US$) of 2007 in Middle East & North Africa (developing only) to that in OECD members?
Your answer should be very brief. 3.21. What is the ratio of the Net Disbursements (current US$) in 2008 in Middle East & North Africa (developing only) to that in OECD members?
Your answer should be compact. 4.45. What is the ratio of the Net Disbursements (current US$) of 2005 in Middle income to that in OECD members?
Your answer should be very brief. 79.35. What is the ratio of the Net Disbursements (current US$) in 2006 in Middle income to that in OECD members?
Offer a terse response. 121.4. What is the ratio of the Net Disbursements (current US$) in 2007 in Middle income to that in OECD members?
Offer a very short reply. 35.14. What is the ratio of the Net Disbursements (current US$) in 2008 in Middle income to that in OECD members?
Ensure brevity in your answer.  29.2. What is the difference between the highest and the second highest Net Disbursements (current US$) of 2005?
Keep it short and to the point. 2.29e+07. What is the difference between the highest and the second highest Net Disbursements (current US$) in 2006?
Your response must be concise. 2.85e+07. What is the difference between the highest and the second highest Net Disbursements (current US$) in 2007?
Give a very brief answer. 2.34e+07. What is the difference between the highest and the second highest Net Disbursements (current US$) in 2008?
Ensure brevity in your answer.  7.46e+06. What is the difference between the highest and the lowest Net Disbursements (current US$) in 2005?
Your answer should be very brief. 4.31e+07. What is the difference between the highest and the lowest Net Disbursements (current US$) of 2006?
Offer a terse response. 4.82e+07. What is the difference between the highest and the lowest Net Disbursements (current US$) in 2007?
Give a very brief answer. 4.51e+07. What is the difference between the highest and the lowest Net Disbursements (current US$) of 2008?
Give a very brief answer. 5.39e+07. 